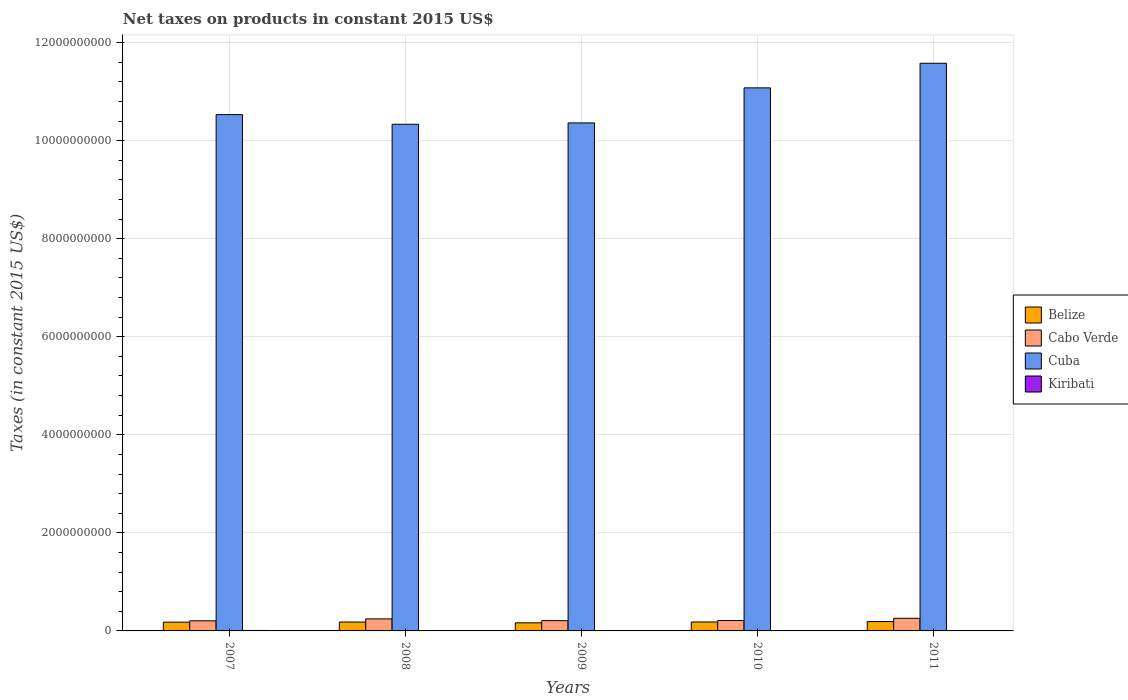How many different coloured bars are there?
Your answer should be compact. 4. How many groups of bars are there?
Your answer should be compact. 5. How many bars are there on the 2nd tick from the right?
Give a very brief answer. 4. What is the label of the 2nd group of bars from the left?
Offer a terse response. 2008. What is the net taxes on products in Cabo Verde in 2009?
Offer a terse response. 2.09e+08. Across all years, what is the maximum net taxes on products in Kiribati?
Keep it short and to the point. 1.00e+07. Across all years, what is the minimum net taxes on products in Cuba?
Ensure brevity in your answer.  1.03e+1. In which year was the net taxes on products in Belize minimum?
Make the answer very short. 2009. What is the total net taxes on products in Kiribati in the graph?
Offer a very short reply. 3.98e+07. What is the difference between the net taxes on products in Belize in 2007 and that in 2011?
Make the answer very short. -1.15e+07. What is the difference between the net taxes on products in Cuba in 2008 and the net taxes on products in Belize in 2009?
Make the answer very short. 1.02e+1. What is the average net taxes on products in Kiribati per year?
Your answer should be compact. 7.95e+06. In the year 2008, what is the difference between the net taxes on products in Cuba and net taxes on products in Belize?
Provide a succinct answer. 1.02e+1. In how many years, is the net taxes on products in Belize greater than 8400000000 US$?
Your answer should be compact. 0. What is the ratio of the net taxes on products in Cabo Verde in 2007 to that in 2008?
Keep it short and to the point. 0.84. Is the net taxes on products in Belize in 2008 less than that in 2010?
Make the answer very short. Yes. Is the difference between the net taxes on products in Cuba in 2008 and 2009 greater than the difference between the net taxes on products in Belize in 2008 and 2009?
Ensure brevity in your answer.  No. What is the difference between the highest and the second highest net taxes on products in Cuba?
Your response must be concise. 5.02e+08. What is the difference between the highest and the lowest net taxes on products in Cuba?
Your answer should be compact. 1.24e+09. Is the sum of the net taxes on products in Belize in 2008 and 2011 greater than the maximum net taxes on products in Cuba across all years?
Keep it short and to the point. No. Is it the case that in every year, the sum of the net taxes on products in Belize and net taxes on products in Cuba is greater than the sum of net taxes on products in Cabo Verde and net taxes on products in Kiribati?
Your response must be concise. Yes. What does the 1st bar from the left in 2008 represents?
Your answer should be compact. Belize. What does the 1st bar from the right in 2008 represents?
Provide a succinct answer. Kiribati. Is it the case that in every year, the sum of the net taxes on products in Belize and net taxes on products in Cabo Verde is greater than the net taxes on products in Cuba?
Make the answer very short. No. How many bars are there?
Your answer should be compact. 20. Are all the bars in the graph horizontal?
Your answer should be very brief. No. How many years are there in the graph?
Give a very brief answer. 5. What is the difference between two consecutive major ticks on the Y-axis?
Your answer should be very brief. 2.00e+09. Are the values on the major ticks of Y-axis written in scientific E-notation?
Give a very brief answer. No. Does the graph contain any zero values?
Your response must be concise. No. Does the graph contain grids?
Provide a short and direct response. Yes. Where does the legend appear in the graph?
Make the answer very short. Center right. How are the legend labels stacked?
Offer a terse response. Vertical. What is the title of the graph?
Make the answer very short. Net taxes on products in constant 2015 US$. Does "Romania" appear as one of the legend labels in the graph?
Make the answer very short. No. What is the label or title of the Y-axis?
Offer a terse response. Taxes (in constant 2015 US$). What is the Taxes (in constant 2015 US$) of Belize in 2007?
Provide a succinct answer. 1.79e+08. What is the Taxes (in constant 2015 US$) of Cabo Verde in 2007?
Ensure brevity in your answer.  2.06e+08. What is the Taxes (in constant 2015 US$) in Cuba in 2007?
Keep it short and to the point. 1.05e+1. What is the Taxes (in constant 2015 US$) of Kiribati in 2007?
Provide a succinct answer. 1.00e+07. What is the Taxes (in constant 2015 US$) in Belize in 2008?
Your answer should be compact. 1.81e+08. What is the Taxes (in constant 2015 US$) in Cabo Verde in 2008?
Your answer should be very brief. 2.45e+08. What is the Taxes (in constant 2015 US$) in Cuba in 2008?
Offer a very short reply. 1.03e+1. What is the Taxes (in constant 2015 US$) in Kiribati in 2008?
Your answer should be compact. 7.26e+06. What is the Taxes (in constant 2015 US$) of Belize in 2009?
Offer a terse response. 1.65e+08. What is the Taxes (in constant 2015 US$) of Cabo Verde in 2009?
Your answer should be very brief. 2.09e+08. What is the Taxes (in constant 2015 US$) in Cuba in 2009?
Offer a very short reply. 1.04e+1. What is the Taxes (in constant 2015 US$) in Kiribati in 2009?
Your answer should be very brief. 7.57e+06. What is the Taxes (in constant 2015 US$) of Belize in 2010?
Your answer should be compact. 1.83e+08. What is the Taxes (in constant 2015 US$) of Cabo Verde in 2010?
Your answer should be very brief. 2.11e+08. What is the Taxes (in constant 2015 US$) in Cuba in 2010?
Make the answer very short. 1.11e+1. What is the Taxes (in constant 2015 US$) of Kiribati in 2010?
Keep it short and to the point. 7.80e+06. What is the Taxes (in constant 2015 US$) in Belize in 2011?
Your answer should be very brief. 1.91e+08. What is the Taxes (in constant 2015 US$) of Cabo Verde in 2011?
Keep it short and to the point. 2.57e+08. What is the Taxes (in constant 2015 US$) of Cuba in 2011?
Your answer should be compact. 1.16e+1. What is the Taxes (in constant 2015 US$) in Kiribati in 2011?
Your answer should be compact. 7.12e+06. Across all years, what is the maximum Taxes (in constant 2015 US$) of Belize?
Give a very brief answer. 1.91e+08. Across all years, what is the maximum Taxes (in constant 2015 US$) in Cabo Verde?
Your response must be concise. 2.57e+08. Across all years, what is the maximum Taxes (in constant 2015 US$) in Cuba?
Offer a terse response. 1.16e+1. Across all years, what is the maximum Taxes (in constant 2015 US$) of Kiribati?
Offer a very short reply. 1.00e+07. Across all years, what is the minimum Taxes (in constant 2015 US$) in Belize?
Give a very brief answer. 1.65e+08. Across all years, what is the minimum Taxes (in constant 2015 US$) in Cabo Verde?
Your response must be concise. 2.06e+08. Across all years, what is the minimum Taxes (in constant 2015 US$) in Cuba?
Offer a very short reply. 1.03e+1. Across all years, what is the minimum Taxes (in constant 2015 US$) of Kiribati?
Provide a succinct answer. 7.12e+06. What is the total Taxes (in constant 2015 US$) of Belize in the graph?
Offer a very short reply. 8.99e+08. What is the total Taxes (in constant 2015 US$) of Cabo Verde in the graph?
Keep it short and to the point. 1.13e+09. What is the total Taxes (in constant 2015 US$) in Cuba in the graph?
Offer a terse response. 5.39e+1. What is the total Taxes (in constant 2015 US$) of Kiribati in the graph?
Your answer should be compact. 3.98e+07. What is the difference between the Taxes (in constant 2015 US$) of Belize in 2007 and that in 2008?
Offer a very short reply. -1.83e+06. What is the difference between the Taxes (in constant 2015 US$) in Cabo Verde in 2007 and that in 2008?
Your answer should be compact. -3.93e+07. What is the difference between the Taxes (in constant 2015 US$) in Cuba in 2007 and that in 2008?
Your answer should be compact. 1.97e+08. What is the difference between the Taxes (in constant 2015 US$) in Kiribati in 2007 and that in 2008?
Your answer should be very brief. 2.77e+06. What is the difference between the Taxes (in constant 2015 US$) in Belize in 2007 and that in 2009?
Offer a very short reply. 1.43e+07. What is the difference between the Taxes (in constant 2015 US$) of Cabo Verde in 2007 and that in 2009?
Provide a short and direct response. -3.21e+06. What is the difference between the Taxes (in constant 2015 US$) in Cuba in 2007 and that in 2009?
Provide a succinct answer. 1.69e+08. What is the difference between the Taxes (in constant 2015 US$) of Kiribati in 2007 and that in 2009?
Give a very brief answer. 2.47e+06. What is the difference between the Taxes (in constant 2015 US$) in Belize in 2007 and that in 2010?
Make the answer very short. -3.17e+06. What is the difference between the Taxes (in constant 2015 US$) of Cabo Verde in 2007 and that in 2010?
Your answer should be compact. -5.19e+06. What is the difference between the Taxes (in constant 2015 US$) of Cuba in 2007 and that in 2010?
Provide a succinct answer. -5.46e+08. What is the difference between the Taxes (in constant 2015 US$) in Kiribati in 2007 and that in 2010?
Your answer should be very brief. 2.23e+06. What is the difference between the Taxes (in constant 2015 US$) of Belize in 2007 and that in 2011?
Your answer should be very brief. -1.15e+07. What is the difference between the Taxes (in constant 2015 US$) of Cabo Verde in 2007 and that in 2011?
Ensure brevity in your answer.  -5.10e+07. What is the difference between the Taxes (in constant 2015 US$) in Cuba in 2007 and that in 2011?
Your answer should be compact. -1.05e+09. What is the difference between the Taxes (in constant 2015 US$) of Kiribati in 2007 and that in 2011?
Ensure brevity in your answer.  2.91e+06. What is the difference between the Taxes (in constant 2015 US$) in Belize in 2008 and that in 2009?
Offer a terse response. 1.61e+07. What is the difference between the Taxes (in constant 2015 US$) in Cabo Verde in 2008 and that in 2009?
Offer a terse response. 3.61e+07. What is the difference between the Taxes (in constant 2015 US$) in Cuba in 2008 and that in 2009?
Your response must be concise. -2.79e+07. What is the difference between the Taxes (in constant 2015 US$) of Kiribati in 2008 and that in 2009?
Your answer should be compact. -3.08e+05. What is the difference between the Taxes (in constant 2015 US$) of Belize in 2008 and that in 2010?
Your response must be concise. -1.35e+06. What is the difference between the Taxes (in constant 2015 US$) of Cabo Verde in 2008 and that in 2010?
Offer a terse response. 3.41e+07. What is the difference between the Taxes (in constant 2015 US$) in Cuba in 2008 and that in 2010?
Offer a very short reply. -7.42e+08. What is the difference between the Taxes (in constant 2015 US$) of Kiribati in 2008 and that in 2010?
Keep it short and to the point. -5.40e+05. What is the difference between the Taxes (in constant 2015 US$) in Belize in 2008 and that in 2011?
Offer a terse response. -9.71e+06. What is the difference between the Taxes (in constant 2015 US$) in Cabo Verde in 2008 and that in 2011?
Your response must be concise. -1.17e+07. What is the difference between the Taxes (in constant 2015 US$) in Cuba in 2008 and that in 2011?
Your answer should be very brief. -1.24e+09. What is the difference between the Taxes (in constant 2015 US$) in Kiribati in 2008 and that in 2011?
Your answer should be compact. 1.40e+05. What is the difference between the Taxes (in constant 2015 US$) of Belize in 2009 and that in 2010?
Keep it short and to the point. -1.75e+07. What is the difference between the Taxes (in constant 2015 US$) of Cabo Verde in 2009 and that in 2010?
Ensure brevity in your answer.  -1.98e+06. What is the difference between the Taxes (in constant 2015 US$) of Cuba in 2009 and that in 2010?
Provide a succinct answer. -7.15e+08. What is the difference between the Taxes (in constant 2015 US$) of Kiribati in 2009 and that in 2010?
Provide a short and direct response. -2.32e+05. What is the difference between the Taxes (in constant 2015 US$) in Belize in 2009 and that in 2011?
Your response must be concise. -2.58e+07. What is the difference between the Taxes (in constant 2015 US$) in Cabo Verde in 2009 and that in 2011?
Offer a terse response. -4.78e+07. What is the difference between the Taxes (in constant 2015 US$) of Cuba in 2009 and that in 2011?
Your answer should be very brief. -1.22e+09. What is the difference between the Taxes (in constant 2015 US$) in Kiribati in 2009 and that in 2011?
Your answer should be very brief. 4.48e+05. What is the difference between the Taxes (in constant 2015 US$) of Belize in 2010 and that in 2011?
Provide a short and direct response. -8.36e+06. What is the difference between the Taxes (in constant 2015 US$) of Cabo Verde in 2010 and that in 2011?
Provide a succinct answer. -4.58e+07. What is the difference between the Taxes (in constant 2015 US$) in Cuba in 2010 and that in 2011?
Make the answer very short. -5.02e+08. What is the difference between the Taxes (in constant 2015 US$) of Kiribati in 2010 and that in 2011?
Your answer should be compact. 6.80e+05. What is the difference between the Taxes (in constant 2015 US$) of Belize in 2007 and the Taxes (in constant 2015 US$) of Cabo Verde in 2008?
Ensure brevity in your answer.  -6.61e+07. What is the difference between the Taxes (in constant 2015 US$) in Belize in 2007 and the Taxes (in constant 2015 US$) in Cuba in 2008?
Your response must be concise. -1.02e+1. What is the difference between the Taxes (in constant 2015 US$) of Belize in 2007 and the Taxes (in constant 2015 US$) of Kiribati in 2008?
Your answer should be compact. 1.72e+08. What is the difference between the Taxes (in constant 2015 US$) of Cabo Verde in 2007 and the Taxes (in constant 2015 US$) of Cuba in 2008?
Give a very brief answer. -1.01e+1. What is the difference between the Taxes (in constant 2015 US$) of Cabo Verde in 2007 and the Taxes (in constant 2015 US$) of Kiribati in 2008?
Your response must be concise. 1.99e+08. What is the difference between the Taxes (in constant 2015 US$) of Cuba in 2007 and the Taxes (in constant 2015 US$) of Kiribati in 2008?
Provide a succinct answer. 1.05e+1. What is the difference between the Taxes (in constant 2015 US$) of Belize in 2007 and the Taxes (in constant 2015 US$) of Cabo Verde in 2009?
Keep it short and to the point. -3.00e+07. What is the difference between the Taxes (in constant 2015 US$) in Belize in 2007 and the Taxes (in constant 2015 US$) in Cuba in 2009?
Offer a very short reply. -1.02e+1. What is the difference between the Taxes (in constant 2015 US$) of Belize in 2007 and the Taxes (in constant 2015 US$) of Kiribati in 2009?
Give a very brief answer. 1.72e+08. What is the difference between the Taxes (in constant 2015 US$) of Cabo Verde in 2007 and the Taxes (in constant 2015 US$) of Cuba in 2009?
Provide a succinct answer. -1.02e+1. What is the difference between the Taxes (in constant 2015 US$) of Cabo Verde in 2007 and the Taxes (in constant 2015 US$) of Kiribati in 2009?
Your answer should be compact. 1.99e+08. What is the difference between the Taxes (in constant 2015 US$) in Cuba in 2007 and the Taxes (in constant 2015 US$) in Kiribati in 2009?
Offer a terse response. 1.05e+1. What is the difference between the Taxes (in constant 2015 US$) in Belize in 2007 and the Taxes (in constant 2015 US$) in Cabo Verde in 2010?
Ensure brevity in your answer.  -3.20e+07. What is the difference between the Taxes (in constant 2015 US$) of Belize in 2007 and the Taxes (in constant 2015 US$) of Cuba in 2010?
Make the answer very short. -1.09e+1. What is the difference between the Taxes (in constant 2015 US$) of Belize in 2007 and the Taxes (in constant 2015 US$) of Kiribati in 2010?
Keep it short and to the point. 1.72e+08. What is the difference between the Taxes (in constant 2015 US$) in Cabo Verde in 2007 and the Taxes (in constant 2015 US$) in Cuba in 2010?
Give a very brief answer. -1.09e+1. What is the difference between the Taxes (in constant 2015 US$) of Cabo Verde in 2007 and the Taxes (in constant 2015 US$) of Kiribati in 2010?
Make the answer very short. 1.98e+08. What is the difference between the Taxes (in constant 2015 US$) in Cuba in 2007 and the Taxes (in constant 2015 US$) in Kiribati in 2010?
Your response must be concise. 1.05e+1. What is the difference between the Taxes (in constant 2015 US$) of Belize in 2007 and the Taxes (in constant 2015 US$) of Cabo Verde in 2011?
Offer a very short reply. -7.78e+07. What is the difference between the Taxes (in constant 2015 US$) in Belize in 2007 and the Taxes (in constant 2015 US$) in Cuba in 2011?
Your answer should be very brief. -1.14e+1. What is the difference between the Taxes (in constant 2015 US$) in Belize in 2007 and the Taxes (in constant 2015 US$) in Kiribati in 2011?
Give a very brief answer. 1.72e+08. What is the difference between the Taxes (in constant 2015 US$) of Cabo Verde in 2007 and the Taxes (in constant 2015 US$) of Cuba in 2011?
Provide a short and direct response. -1.14e+1. What is the difference between the Taxes (in constant 2015 US$) in Cabo Verde in 2007 and the Taxes (in constant 2015 US$) in Kiribati in 2011?
Make the answer very short. 1.99e+08. What is the difference between the Taxes (in constant 2015 US$) in Cuba in 2007 and the Taxes (in constant 2015 US$) in Kiribati in 2011?
Your answer should be very brief. 1.05e+1. What is the difference between the Taxes (in constant 2015 US$) of Belize in 2008 and the Taxes (in constant 2015 US$) of Cabo Verde in 2009?
Provide a succinct answer. -2.82e+07. What is the difference between the Taxes (in constant 2015 US$) of Belize in 2008 and the Taxes (in constant 2015 US$) of Cuba in 2009?
Offer a very short reply. -1.02e+1. What is the difference between the Taxes (in constant 2015 US$) in Belize in 2008 and the Taxes (in constant 2015 US$) in Kiribati in 2009?
Keep it short and to the point. 1.74e+08. What is the difference between the Taxes (in constant 2015 US$) of Cabo Verde in 2008 and the Taxes (in constant 2015 US$) of Cuba in 2009?
Keep it short and to the point. -1.01e+1. What is the difference between the Taxes (in constant 2015 US$) in Cabo Verde in 2008 and the Taxes (in constant 2015 US$) in Kiribati in 2009?
Give a very brief answer. 2.38e+08. What is the difference between the Taxes (in constant 2015 US$) of Cuba in 2008 and the Taxes (in constant 2015 US$) of Kiribati in 2009?
Give a very brief answer. 1.03e+1. What is the difference between the Taxes (in constant 2015 US$) in Belize in 2008 and the Taxes (in constant 2015 US$) in Cabo Verde in 2010?
Your answer should be compact. -3.02e+07. What is the difference between the Taxes (in constant 2015 US$) in Belize in 2008 and the Taxes (in constant 2015 US$) in Cuba in 2010?
Your answer should be compact. -1.09e+1. What is the difference between the Taxes (in constant 2015 US$) in Belize in 2008 and the Taxes (in constant 2015 US$) in Kiribati in 2010?
Your response must be concise. 1.73e+08. What is the difference between the Taxes (in constant 2015 US$) of Cabo Verde in 2008 and the Taxes (in constant 2015 US$) of Cuba in 2010?
Ensure brevity in your answer.  -1.08e+1. What is the difference between the Taxes (in constant 2015 US$) of Cabo Verde in 2008 and the Taxes (in constant 2015 US$) of Kiribati in 2010?
Offer a terse response. 2.38e+08. What is the difference between the Taxes (in constant 2015 US$) of Cuba in 2008 and the Taxes (in constant 2015 US$) of Kiribati in 2010?
Your answer should be compact. 1.03e+1. What is the difference between the Taxes (in constant 2015 US$) in Belize in 2008 and the Taxes (in constant 2015 US$) in Cabo Verde in 2011?
Offer a very short reply. -7.59e+07. What is the difference between the Taxes (in constant 2015 US$) in Belize in 2008 and the Taxes (in constant 2015 US$) in Cuba in 2011?
Keep it short and to the point. -1.14e+1. What is the difference between the Taxes (in constant 2015 US$) in Belize in 2008 and the Taxes (in constant 2015 US$) in Kiribati in 2011?
Your answer should be very brief. 1.74e+08. What is the difference between the Taxes (in constant 2015 US$) in Cabo Verde in 2008 and the Taxes (in constant 2015 US$) in Cuba in 2011?
Keep it short and to the point. -1.13e+1. What is the difference between the Taxes (in constant 2015 US$) of Cabo Verde in 2008 and the Taxes (in constant 2015 US$) of Kiribati in 2011?
Ensure brevity in your answer.  2.38e+08. What is the difference between the Taxes (in constant 2015 US$) in Cuba in 2008 and the Taxes (in constant 2015 US$) in Kiribati in 2011?
Your response must be concise. 1.03e+1. What is the difference between the Taxes (in constant 2015 US$) of Belize in 2009 and the Taxes (in constant 2015 US$) of Cabo Verde in 2010?
Keep it short and to the point. -4.63e+07. What is the difference between the Taxes (in constant 2015 US$) of Belize in 2009 and the Taxes (in constant 2015 US$) of Cuba in 2010?
Your answer should be compact. -1.09e+1. What is the difference between the Taxes (in constant 2015 US$) of Belize in 2009 and the Taxes (in constant 2015 US$) of Kiribati in 2010?
Your response must be concise. 1.57e+08. What is the difference between the Taxes (in constant 2015 US$) in Cabo Verde in 2009 and the Taxes (in constant 2015 US$) in Cuba in 2010?
Keep it short and to the point. -1.09e+1. What is the difference between the Taxes (in constant 2015 US$) in Cabo Verde in 2009 and the Taxes (in constant 2015 US$) in Kiribati in 2010?
Offer a very short reply. 2.02e+08. What is the difference between the Taxes (in constant 2015 US$) of Cuba in 2009 and the Taxes (in constant 2015 US$) of Kiribati in 2010?
Your answer should be compact. 1.04e+1. What is the difference between the Taxes (in constant 2015 US$) of Belize in 2009 and the Taxes (in constant 2015 US$) of Cabo Verde in 2011?
Provide a short and direct response. -9.21e+07. What is the difference between the Taxes (in constant 2015 US$) of Belize in 2009 and the Taxes (in constant 2015 US$) of Cuba in 2011?
Ensure brevity in your answer.  -1.14e+1. What is the difference between the Taxes (in constant 2015 US$) of Belize in 2009 and the Taxes (in constant 2015 US$) of Kiribati in 2011?
Your response must be concise. 1.58e+08. What is the difference between the Taxes (in constant 2015 US$) in Cabo Verde in 2009 and the Taxes (in constant 2015 US$) in Cuba in 2011?
Offer a very short reply. -1.14e+1. What is the difference between the Taxes (in constant 2015 US$) in Cabo Verde in 2009 and the Taxes (in constant 2015 US$) in Kiribati in 2011?
Offer a terse response. 2.02e+08. What is the difference between the Taxes (in constant 2015 US$) in Cuba in 2009 and the Taxes (in constant 2015 US$) in Kiribati in 2011?
Make the answer very short. 1.04e+1. What is the difference between the Taxes (in constant 2015 US$) of Belize in 2010 and the Taxes (in constant 2015 US$) of Cabo Verde in 2011?
Your response must be concise. -7.46e+07. What is the difference between the Taxes (in constant 2015 US$) of Belize in 2010 and the Taxes (in constant 2015 US$) of Cuba in 2011?
Provide a short and direct response. -1.14e+1. What is the difference between the Taxes (in constant 2015 US$) of Belize in 2010 and the Taxes (in constant 2015 US$) of Kiribati in 2011?
Offer a terse response. 1.75e+08. What is the difference between the Taxes (in constant 2015 US$) in Cabo Verde in 2010 and the Taxes (in constant 2015 US$) in Cuba in 2011?
Keep it short and to the point. -1.14e+1. What is the difference between the Taxes (in constant 2015 US$) in Cabo Verde in 2010 and the Taxes (in constant 2015 US$) in Kiribati in 2011?
Give a very brief answer. 2.04e+08. What is the difference between the Taxes (in constant 2015 US$) in Cuba in 2010 and the Taxes (in constant 2015 US$) in Kiribati in 2011?
Your answer should be compact. 1.11e+1. What is the average Taxes (in constant 2015 US$) of Belize per year?
Give a very brief answer. 1.80e+08. What is the average Taxes (in constant 2015 US$) in Cabo Verde per year?
Ensure brevity in your answer.  2.26e+08. What is the average Taxes (in constant 2015 US$) in Cuba per year?
Provide a succinct answer. 1.08e+1. What is the average Taxes (in constant 2015 US$) in Kiribati per year?
Offer a terse response. 7.95e+06. In the year 2007, what is the difference between the Taxes (in constant 2015 US$) in Belize and Taxes (in constant 2015 US$) in Cabo Verde?
Offer a terse response. -2.68e+07. In the year 2007, what is the difference between the Taxes (in constant 2015 US$) of Belize and Taxes (in constant 2015 US$) of Cuba?
Provide a short and direct response. -1.04e+1. In the year 2007, what is the difference between the Taxes (in constant 2015 US$) of Belize and Taxes (in constant 2015 US$) of Kiribati?
Your response must be concise. 1.69e+08. In the year 2007, what is the difference between the Taxes (in constant 2015 US$) of Cabo Verde and Taxes (in constant 2015 US$) of Cuba?
Your answer should be very brief. -1.03e+1. In the year 2007, what is the difference between the Taxes (in constant 2015 US$) in Cabo Verde and Taxes (in constant 2015 US$) in Kiribati?
Offer a terse response. 1.96e+08. In the year 2007, what is the difference between the Taxes (in constant 2015 US$) in Cuba and Taxes (in constant 2015 US$) in Kiribati?
Provide a succinct answer. 1.05e+1. In the year 2008, what is the difference between the Taxes (in constant 2015 US$) in Belize and Taxes (in constant 2015 US$) in Cabo Verde?
Your answer should be very brief. -6.43e+07. In the year 2008, what is the difference between the Taxes (in constant 2015 US$) in Belize and Taxes (in constant 2015 US$) in Cuba?
Offer a very short reply. -1.02e+1. In the year 2008, what is the difference between the Taxes (in constant 2015 US$) in Belize and Taxes (in constant 2015 US$) in Kiribati?
Give a very brief answer. 1.74e+08. In the year 2008, what is the difference between the Taxes (in constant 2015 US$) of Cabo Verde and Taxes (in constant 2015 US$) of Cuba?
Keep it short and to the point. -1.01e+1. In the year 2008, what is the difference between the Taxes (in constant 2015 US$) of Cabo Verde and Taxes (in constant 2015 US$) of Kiribati?
Give a very brief answer. 2.38e+08. In the year 2008, what is the difference between the Taxes (in constant 2015 US$) of Cuba and Taxes (in constant 2015 US$) of Kiribati?
Keep it short and to the point. 1.03e+1. In the year 2009, what is the difference between the Taxes (in constant 2015 US$) in Belize and Taxes (in constant 2015 US$) in Cabo Verde?
Offer a terse response. -4.43e+07. In the year 2009, what is the difference between the Taxes (in constant 2015 US$) in Belize and Taxes (in constant 2015 US$) in Cuba?
Ensure brevity in your answer.  -1.02e+1. In the year 2009, what is the difference between the Taxes (in constant 2015 US$) of Belize and Taxes (in constant 2015 US$) of Kiribati?
Ensure brevity in your answer.  1.58e+08. In the year 2009, what is the difference between the Taxes (in constant 2015 US$) in Cabo Verde and Taxes (in constant 2015 US$) in Cuba?
Your answer should be very brief. -1.02e+1. In the year 2009, what is the difference between the Taxes (in constant 2015 US$) of Cabo Verde and Taxes (in constant 2015 US$) of Kiribati?
Offer a terse response. 2.02e+08. In the year 2009, what is the difference between the Taxes (in constant 2015 US$) in Cuba and Taxes (in constant 2015 US$) in Kiribati?
Give a very brief answer. 1.04e+1. In the year 2010, what is the difference between the Taxes (in constant 2015 US$) of Belize and Taxes (in constant 2015 US$) of Cabo Verde?
Give a very brief answer. -2.88e+07. In the year 2010, what is the difference between the Taxes (in constant 2015 US$) in Belize and Taxes (in constant 2015 US$) in Cuba?
Provide a short and direct response. -1.09e+1. In the year 2010, what is the difference between the Taxes (in constant 2015 US$) of Belize and Taxes (in constant 2015 US$) of Kiribati?
Ensure brevity in your answer.  1.75e+08. In the year 2010, what is the difference between the Taxes (in constant 2015 US$) of Cabo Verde and Taxes (in constant 2015 US$) of Cuba?
Offer a terse response. -1.09e+1. In the year 2010, what is the difference between the Taxes (in constant 2015 US$) in Cabo Verde and Taxes (in constant 2015 US$) in Kiribati?
Make the answer very short. 2.04e+08. In the year 2010, what is the difference between the Taxes (in constant 2015 US$) in Cuba and Taxes (in constant 2015 US$) in Kiribati?
Give a very brief answer. 1.11e+1. In the year 2011, what is the difference between the Taxes (in constant 2015 US$) of Belize and Taxes (in constant 2015 US$) of Cabo Verde?
Provide a succinct answer. -6.62e+07. In the year 2011, what is the difference between the Taxes (in constant 2015 US$) of Belize and Taxes (in constant 2015 US$) of Cuba?
Your response must be concise. -1.14e+1. In the year 2011, what is the difference between the Taxes (in constant 2015 US$) of Belize and Taxes (in constant 2015 US$) of Kiribati?
Offer a terse response. 1.84e+08. In the year 2011, what is the difference between the Taxes (in constant 2015 US$) in Cabo Verde and Taxes (in constant 2015 US$) in Cuba?
Your response must be concise. -1.13e+1. In the year 2011, what is the difference between the Taxes (in constant 2015 US$) in Cabo Verde and Taxes (in constant 2015 US$) in Kiribati?
Offer a very short reply. 2.50e+08. In the year 2011, what is the difference between the Taxes (in constant 2015 US$) in Cuba and Taxes (in constant 2015 US$) in Kiribati?
Provide a succinct answer. 1.16e+1. What is the ratio of the Taxes (in constant 2015 US$) of Cabo Verde in 2007 to that in 2008?
Give a very brief answer. 0.84. What is the ratio of the Taxes (in constant 2015 US$) of Kiribati in 2007 to that in 2008?
Ensure brevity in your answer.  1.38. What is the ratio of the Taxes (in constant 2015 US$) of Belize in 2007 to that in 2009?
Provide a short and direct response. 1.09. What is the ratio of the Taxes (in constant 2015 US$) of Cabo Verde in 2007 to that in 2009?
Keep it short and to the point. 0.98. What is the ratio of the Taxes (in constant 2015 US$) in Cuba in 2007 to that in 2009?
Your answer should be very brief. 1.02. What is the ratio of the Taxes (in constant 2015 US$) of Kiribati in 2007 to that in 2009?
Keep it short and to the point. 1.33. What is the ratio of the Taxes (in constant 2015 US$) in Belize in 2007 to that in 2010?
Offer a very short reply. 0.98. What is the ratio of the Taxes (in constant 2015 US$) in Cabo Verde in 2007 to that in 2010?
Provide a short and direct response. 0.98. What is the ratio of the Taxes (in constant 2015 US$) of Cuba in 2007 to that in 2010?
Your response must be concise. 0.95. What is the ratio of the Taxes (in constant 2015 US$) of Kiribati in 2007 to that in 2010?
Make the answer very short. 1.29. What is the ratio of the Taxes (in constant 2015 US$) in Belize in 2007 to that in 2011?
Your answer should be compact. 0.94. What is the ratio of the Taxes (in constant 2015 US$) in Cabo Verde in 2007 to that in 2011?
Your answer should be very brief. 0.8. What is the ratio of the Taxes (in constant 2015 US$) of Cuba in 2007 to that in 2011?
Keep it short and to the point. 0.91. What is the ratio of the Taxes (in constant 2015 US$) in Kiribati in 2007 to that in 2011?
Provide a succinct answer. 1.41. What is the ratio of the Taxes (in constant 2015 US$) in Belize in 2008 to that in 2009?
Keep it short and to the point. 1.1. What is the ratio of the Taxes (in constant 2015 US$) in Cabo Verde in 2008 to that in 2009?
Your answer should be very brief. 1.17. What is the ratio of the Taxes (in constant 2015 US$) of Cuba in 2008 to that in 2009?
Offer a very short reply. 1. What is the ratio of the Taxes (in constant 2015 US$) of Kiribati in 2008 to that in 2009?
Offer a very short reply. 0.96. What is the ratio of the Taxes (in constant 2015 US$) of Cabo Verde in 2008 to that in 2010?
Ensure brevity in your answer.  1.16. What is the ratio of the Taxes (in constant 2015 US$) of Cuba in 2008 to that in 2010?
Give a very brief answer. 0.93. What is the ratio of the Taxes (in constant 2015 US$) of Kiribati in 2008 to that in 2010?
Your response must be concise. 0.93. What is the ratio of the Taxes (in constant 2015 US$) of Belize in 2008 to that in 2011?
Provide a short and direct response. 0.95. What is the ratio of the Taxes (in constant 2015 US$) in Cabo Verde in 2008 to that in 2011?
Your response must be concise. 0.95. What is the ratio of the Taxes (in constant 2015 US$) in Cuba in 2008 to that in 2011?
Your answer should be very brief. 0.89. What is the ratio of the Taxes (in constant 2015 US$) of Kiribati in 2008 to that in 2011?
Ensure brevity in your answer.  1.02. What is the ratio of the Taxes (in constant 2015 US$) in Belize in 2009 to that in 2010?
Your answer should be very brief. 0.9. What is the ratio of the Taxes (in constant 2015 US$) in Cabo Verde in 2009 to that in 2010?
Provide a short and direct response. 0.99. What is the ratio of the Taxes (in constant 2015 US$) of Cuba in 2009 to that in 2010?
Offer a very short reply. 0.94. What is the ratio of the Taxes (in constant 2015 US$) in Kiribati in 2009 to that in 2010?
Give a very brief answer. 0.97. What is the ratio of the Taxes (in constant 2015 US$) of Belize in 2009 to that in 2011?
Give a very brief answer. 0.86. What is the ratio of the Taxes (in constant 2015 US$) of Cabo Verde in 2009 to that in 2011?
Provide a succinct answer. 0.81. What is the ratio of the Taxes (in constant 2015 US$) of Cuba in 2009 to that in 2011?
Provide a succinct answer. 0.89. What is the ratio of the Taxes (in constant 2015 US$) of Kiribati in 2009 to that in 2011?
Your answer should be very brief. 1.06. What is the ratio of the Taxes (in constant 2015 US$) of Belize in 2010 to that in 2011?
Make the answer very short. 0.96. What is the ratio of the Taxes (in constant 2015 US$) of Cabo Verde in 2010 to that in 2011?
Offer a very short reply. 0.82. What is the ratio of the Taxes (in constant 2015 US$) of Cuba in 2010 to that in 2011?
Keep it short and to the point. 0.96. What is the ratio of the Taxes (in constant 2015 US$) in Kiribati in 2010 to that in 2011?
Your response must be concise. 1.1. What is the difference between the highest and the second highest Taxes (in constant 2015 US$) of Belize?
Keep it short and to the point. 8.36e+06. What is the difference between the highest and the second highest Taxes (in constant 2015 US$) in Cabo Verde?
Your answer should be very brief. 1.17e+07. What is the difference between the highest and the second highest Taxes (in constant 2015 US$) of Cuba?
Offer a terse response. 5.02e+08. What is the difference between the highest and the second highest Taxes (in constant 2015 US$) of Kiribati?
Ensure brevity in your answer.  2.23e+06. What is the difference between the highest and the lowest Taxes (in constant 2015 US$) in Belize?
Offer a terse response. 2.58e+07. What is the difference between the highest and the lowest Taxes (in constant 2015 US$) of Cabo Verde?
Provide a short and direct response. 5.10e+07. What is the difference between the highest and the lowest Taxes (in constant 2015 US$) in Cuba?
Keep it short and to the point. 1.24e+09. What is the difference between the highest and the lowest Taxes (in constant 2015 US$) of Kiribati?
Make the answer very short. 2.91e+06. 